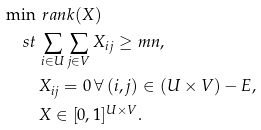Convert formula to latex. <formula><loc_0><loc_0><loc_500><loc_500>\min \, & \ r a n k ( X ) \\ \ s t \, & \sum _ { i \in U } \sum _ { j \in V } X _ { i j } \geq m n , \\ & X _ { i j } = 0 \, \forall \, ( i , j ) \in ( U \times V ) - E , \\ & X \in [ 0 , 1 ] ^ { U \times V } .</formula> 